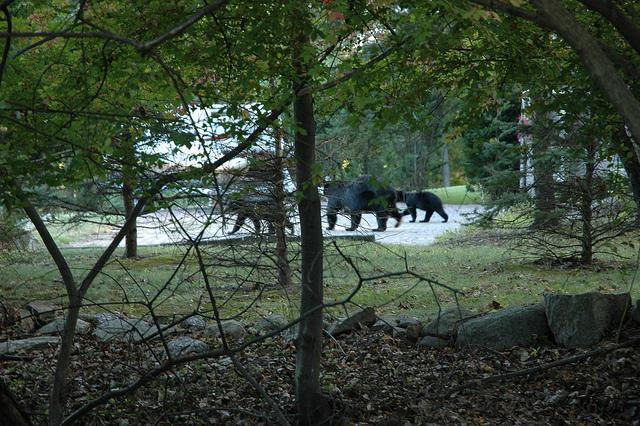How many bears are here?
Give a very brief answer. 3. 